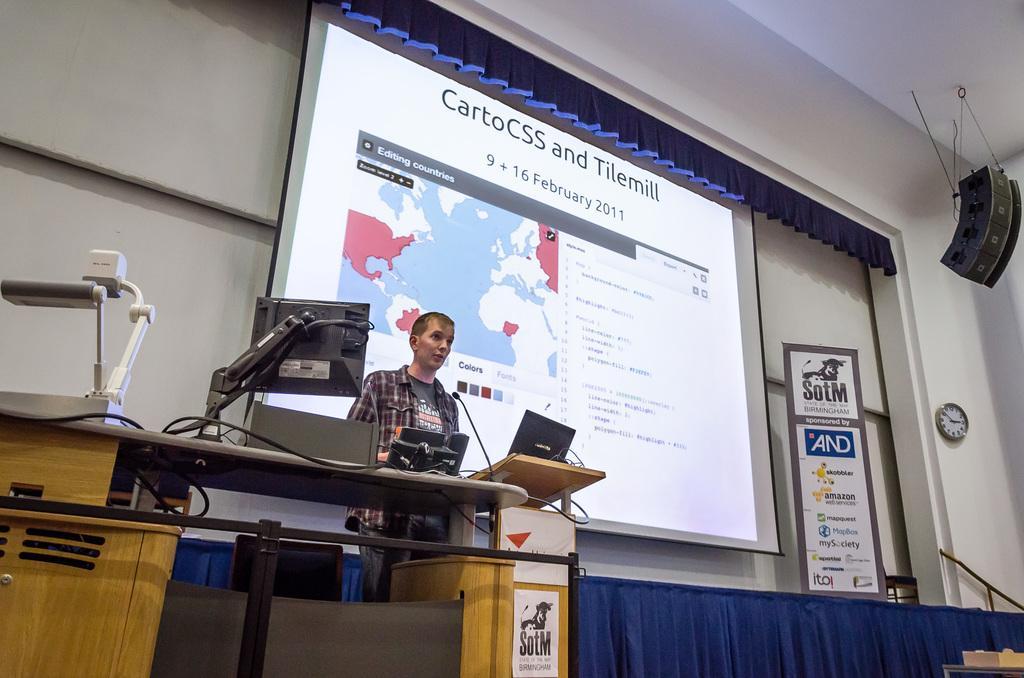Can you describe this image briefly? In this image in front there is a table. On top of it there is a computer, laptop, mic and a few other objects. In front of the table there is a person. Behind him there is a table. On top of it there is a blue color cloth. In the center of the image there is a screen. Beside the screen there is a board. There is a clock on the wall. On top of the image there is some object hanged to the ceiling. 